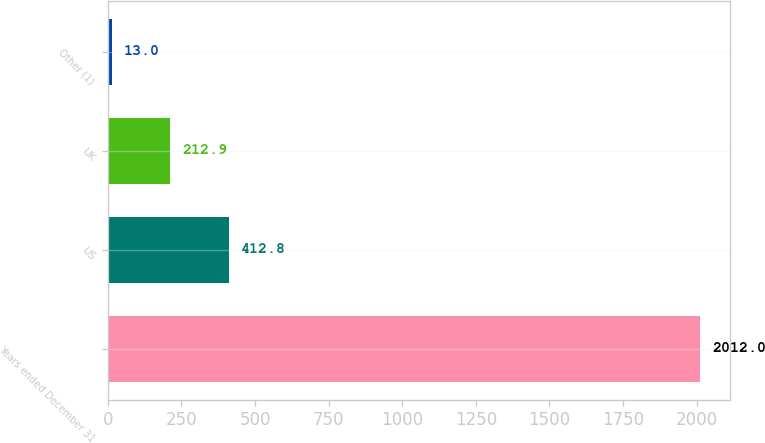Convert chart to OTSL. <chart><loc_0><loc_0><loc_500><loc_500><bar_chart><fcel>Years ended December 31<fcel>US<fcel>UK<fcel>Other (1)<nl><fcel>2012<fcel>412.8<fcel>212.9<fcel>13<nl></chart> 